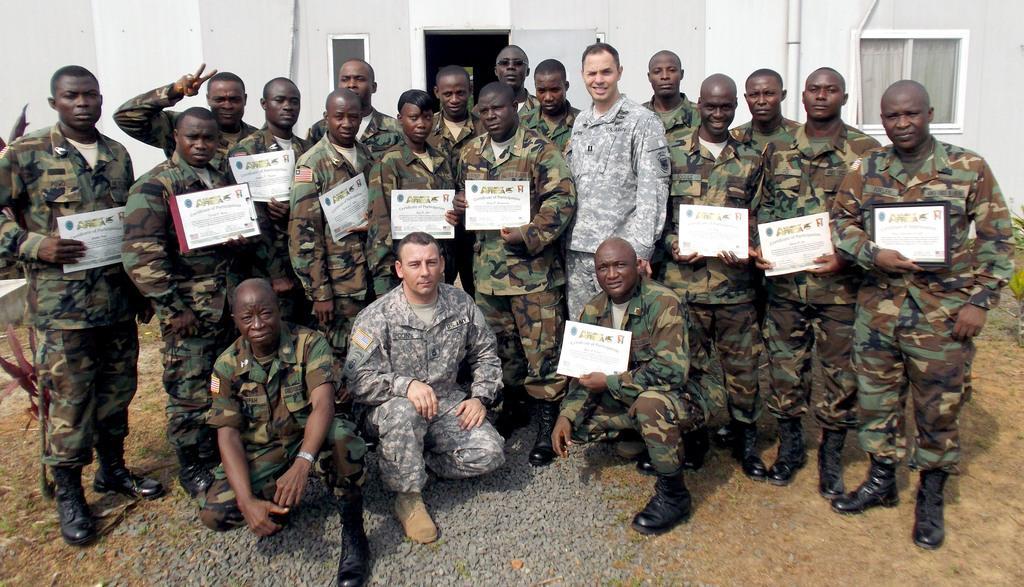How would you summarize this image in a sentence or two? In this picture I can see group of people holding certificates, there are plants, and in the background there is a building. 